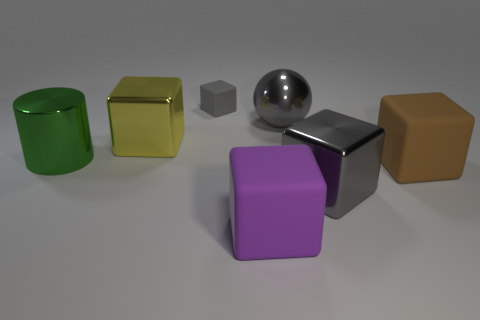Subtract all yellow blocks. How many blocks are left? 4 Subtract 2 blocks. How many blocks are left? 3 Subtract all big yellow blocks. How many blocks are left? 4 Subtract all red blocks. Subtract all blue cylinders. How many blocks are left? 5 Add 3 large things. How many objects exist? 10 Subtract all cubes. How many objects are left? 2 Add 7 large gray spheres. How many large gray spheres are left? 8 Add 5 big metal cylinders. How many big metal cylinders exist? 6 Subtract 0 red blocks. How many objects are left? 7 Subtract all tiny matte cylinders. Subtract all green cylinders. How many objects are left? 6 